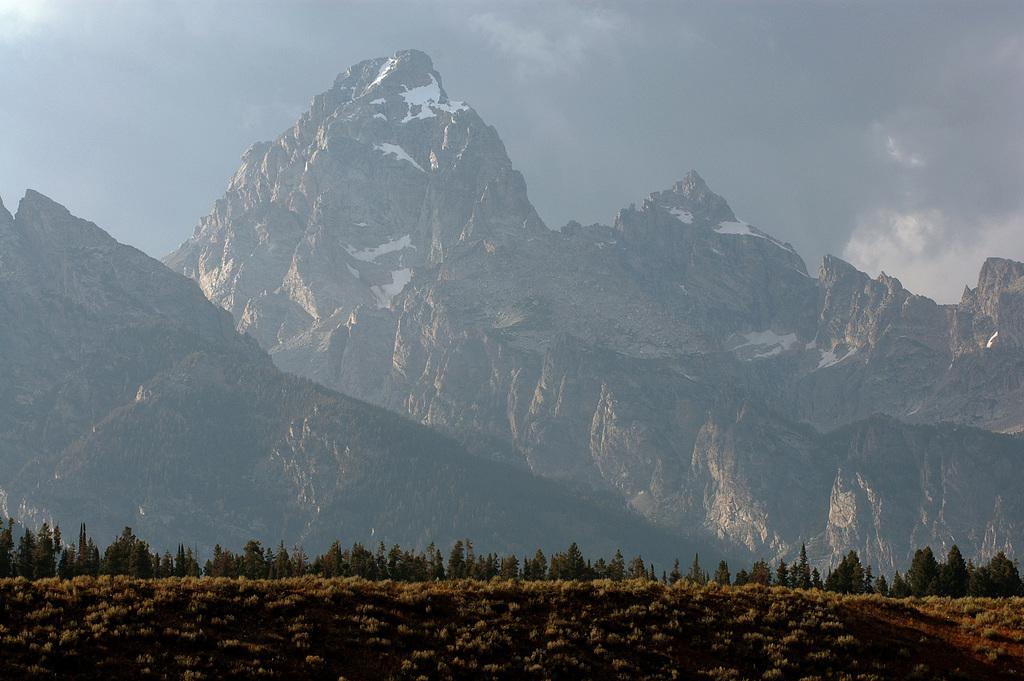What type of surface is on the floor in the image? There is grass on the floor in the image. What can be seen in the background of the image? There are trees and mountains in the backdrop of the image. What is the condition of the mountains in the image? The mountains have some snow on them. How would you describe the sky in the image? The sky is cloudy in the image. What type of card is being used to care for the grass in the image? There is no card or any indication of caring for the grass in the image; it is simply a grassy floor. 